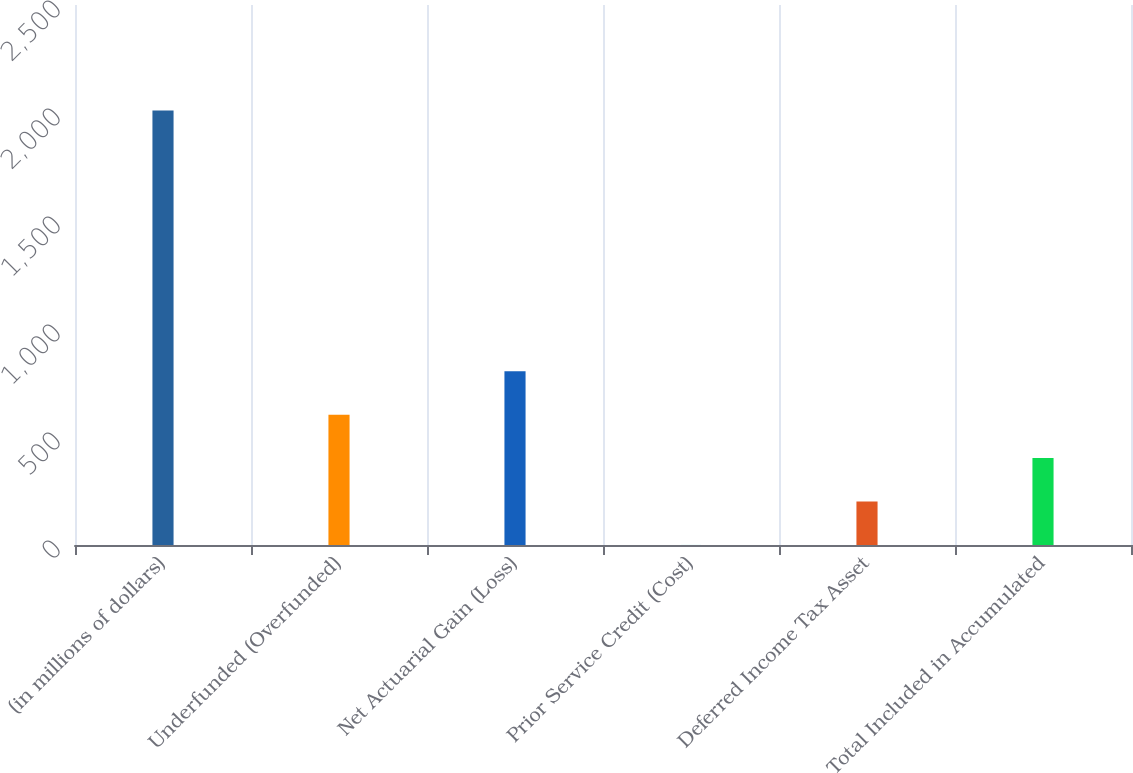Convert chart. <chart><loc_0><loc_0><loc_500><loc_500><bar_chart><fcel>(in millions of dollars)<fcel>Underfunded (Overfunded)<fcel>Net Actuarial Gain (Loss)<fcel>Prior Service Credit (Cost)<fcel>Deferred Income Tax Asset<fcel>Total Included in Accumulated<nl><fcel>2011<fcel>603.44<fcel>804.52<fcel>0.2<fcel>201.28<fcel>402.36<nl></chart> 